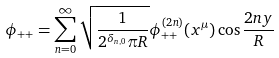<formula> <loc_0><loc_0><loc_500><loc_500>\phi _ { + + } = \sum ^ { \infty } _ { n = 0 } \sqrt { \frac { 1 } { 2 ^ { \delta _ { n , 0 } } \pi R } } \phi ^ { ( 2 n ) } _ { + + } ( x ^ { \mu } ) \cos \frac { 2 n y } { R }</formula> 